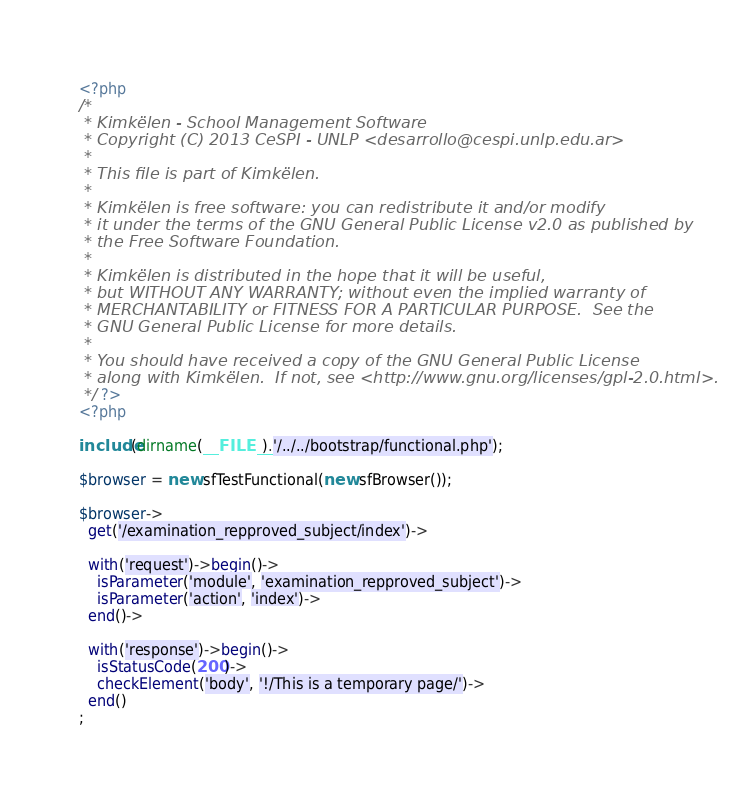Convert code to text. <code><loc_0><loc_0><loc_500><loc_500><_PHP_><?php 
/*
 * Kimkëlen - School Management Software
 * Copyright (C) 2013 CeSPI - UNLP <desarrollo@cespi.unlp.edu.ar>
 *
 * This file is part of Kimkëlen.
 *
 * Kimkëlen is free software: you can redistribute it and/or modify
 * it under the terms of the GNU General Public License v2.0 as published by
 * the Free Software Foundation.
 *
 * Kimkëlen is distributed in the hope that it will be useful,
 * but WITHOUT ANY WARRANTY; without even the implied warranty of
 * MERCHANTABILITY or FITNESS FOR A PARTICULAR PURPOSE.  See the
 * GNU General Public License for more details.
 *
 * You should have received a copy of the GNU General Public License
 * along with Kimkëlen.  If not, see <http://www.gnu.org/licenses/gpl-2.0.html>.
 */ ?>
<?php

include(dirname(__FILE__).'/../../bootstrap/functional.php');

$browser = new sfTestFunctional(new sfBrowser());

$browser->
  get('/examination_repproved_subject/index')->

  with('request')->begin()->
    isParameter('module', 'examination_repproved_subject')->
    isParameter('action', 'index')->
  end()->

  with('response')->begin()->
    isStatusCode(200)->
    checkElement('body', '!/This is a temporary page/')->
  end()
;</code> 